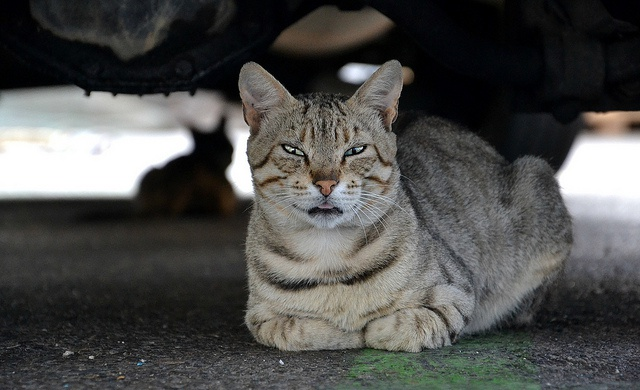Describe the objects in this image and their specific colors. I can see cat in black, gray, and darkgray tones and car in black and gray tones in this image. 